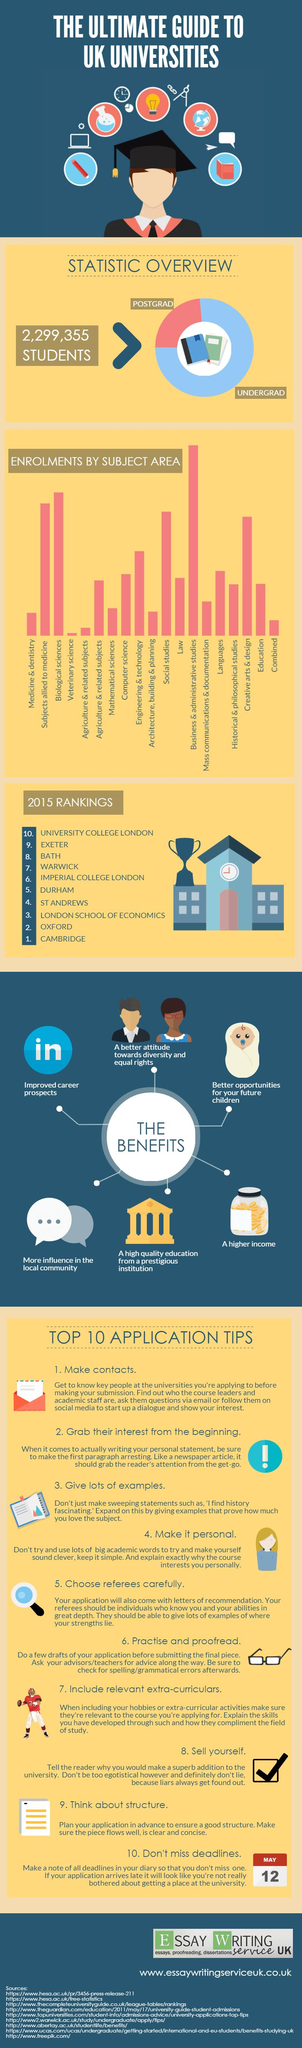Point out several critical features in this image. The highest enrollment in a specific subject area is in business and administrative studies. The second highest subject enrollment is in the field of biological sciences. The subject enrollment in agriculture and related subjects is the second lowest out of all areas. En el área en la que el número de inscripciones es el menor se encuentra la ciencia veterinaria. 